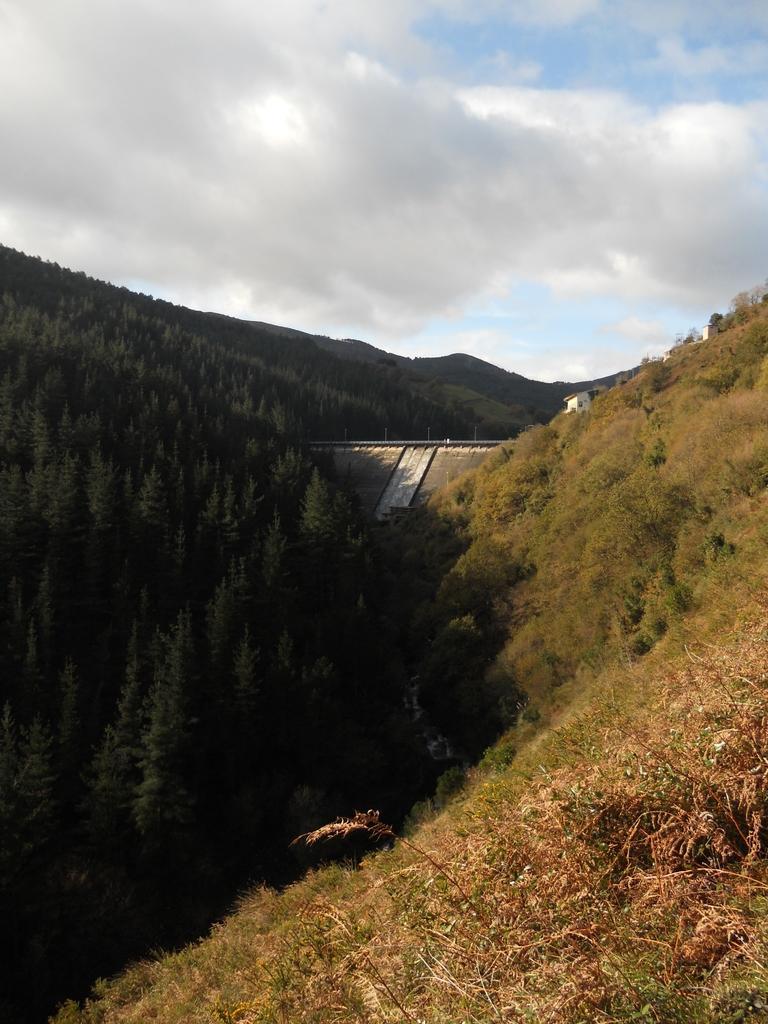Please provide a concise description of this image. This is an outside view. At the bottom of the image I can see many trees and hills. In the middle of the image there is a bridge and I can see a house. At the top of the image I can see the sky and clouds. 